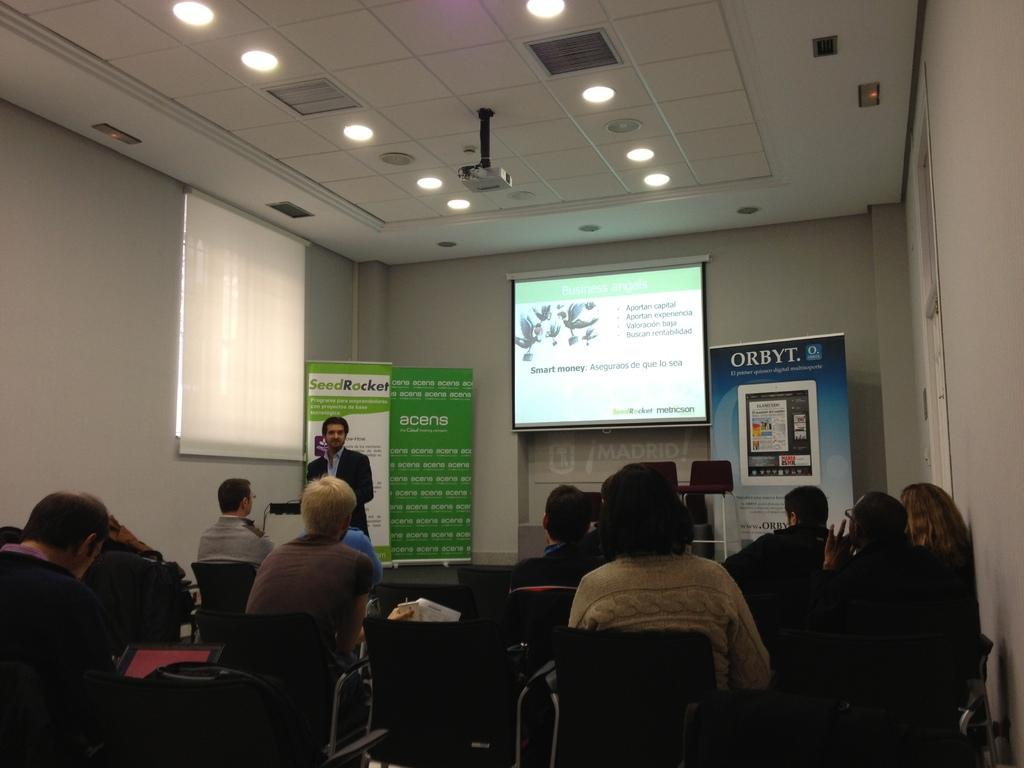What are the people in the image doing? There is a group of people sitting in the image. Can you describe the man in the background? There is a man standing in the background. What is hanging or displayed in the image? There is a banner in the image. What device is present for displaying visuals? There is a projector in the image. What type of structure can be seen in the image? There is a wall in the image. Is there any source of natural light visible in the image? There is a window in the image. What is the source of light visible at the top of the image? There is a light visible at the top of the image. What type of hat is the man wearing in the scene? There is no man wearing a hat in the image, and the term "scene" is not applicable as it refers to a sequence of events or actions, not a single image. How many stars can be seen through the window in the image? There is no mention of stars in the image, and the window is not transparent enough to see stars. 